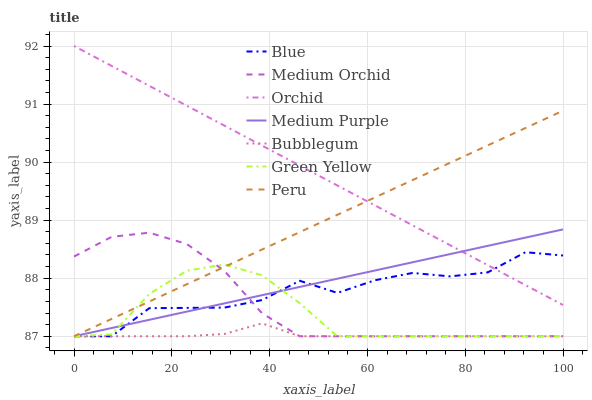Does Bubblegum have the minimum area under the curve?
Answer yes or no. Yes. Does Orchid have the maximum area under the curve?
Answer yes or no. Yes. Does Medium Orchid have the minimum area under the curve?
Answer yes or no. No. Does Medium Orchid have the maximum area under the curve?
Answer yes or no. No. Is Peru the smoothest?
Answer yes or no. Yes. Is Blue the roughest?
Answer yes or no. Yes. Is Medium Orchid the smoothest?
Answer yes or no. No. Is Medium Orchid the roughest?
Answer yes or no. No. Does Blue have the lowest value?
Answer yes or no. Yes. Does Orchid have the lowest value?
Answer yes or no. No. Does Orchid have the highest value?
Answer yes or no. Yes. Does Medium Orchid have the highest value?
Answer yes or no. No. Is Green Yellow less than Orchid?
Answer yes or no. Yes. Is Orchid greater than Medium Orchid?
Answer yes or no. Yes. Does Blue intersect Bubblegum?
Answer yes or no. Yes. Is Blue less than Bubblegum?
Answer yes or no. No. Is Blue greater than Bubblegum?
Answer yes or no. No. Does Green Yellow intersect Orchid?
Answer yes or no. No. 